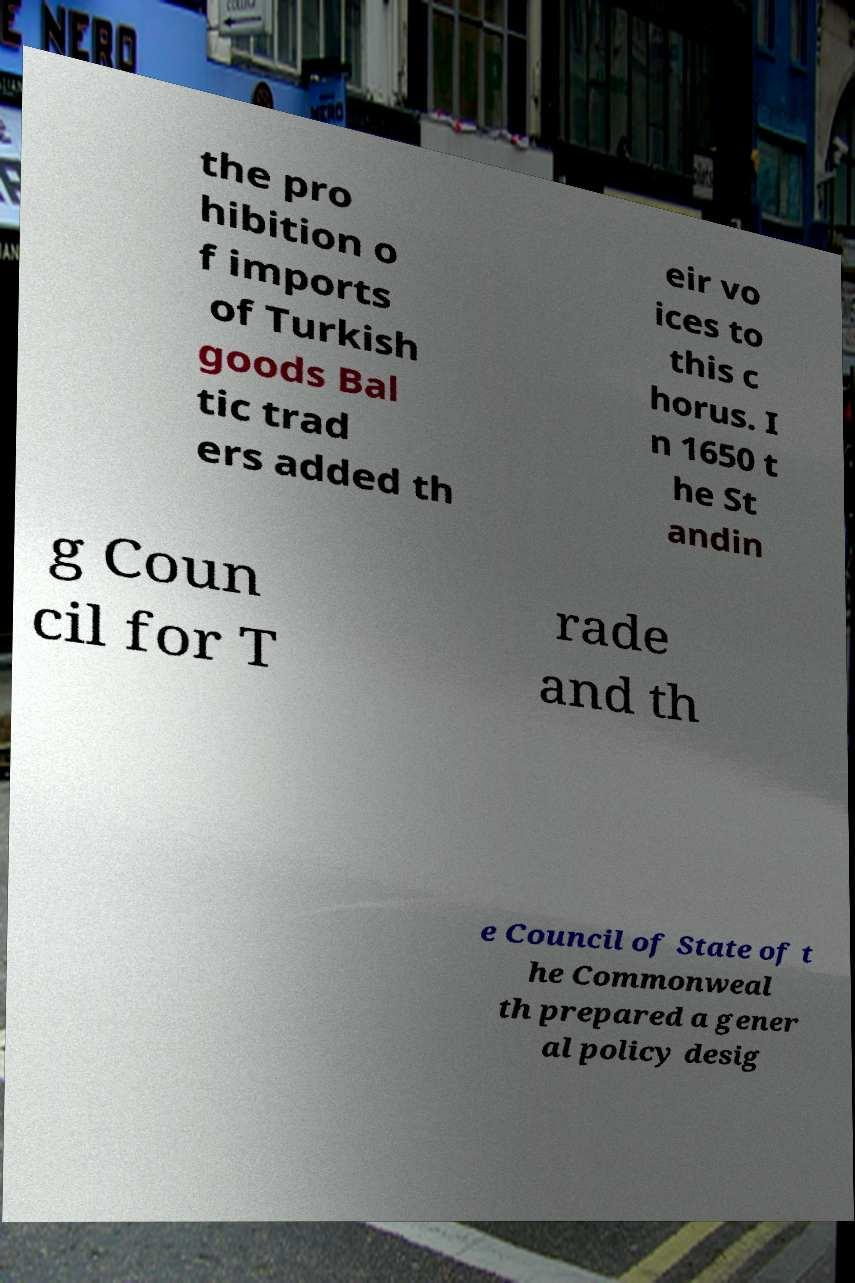For documentation purposes, I need the text within this image transcribed. Could you provide that? the pro hibition o f imports of Turkish goods Bal tic trad ers added th eir vo ices to this c horus. I n 1650 t he St andin g Coun cil for T rade and th e Council of State of t he Commonweal th prepared a gener al policy desig 